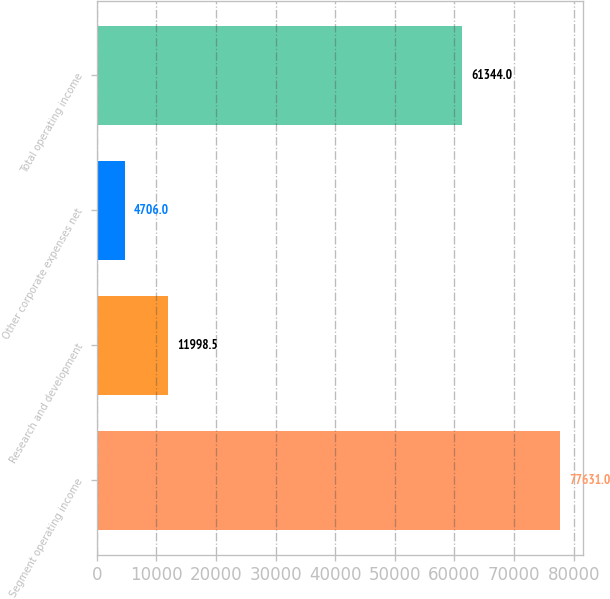Convert chart to OTSL. <chart><loc_0><loc_0><loc_500><loc_500><bar_chart><fcel>Segment operating income<fcel>Research and development<fcel>Other corporate expenses net<fcel>Total operating income<nl><fcel>77631<fcel>11998.5<fcel>4706<fcel>61344<nl></chart> 